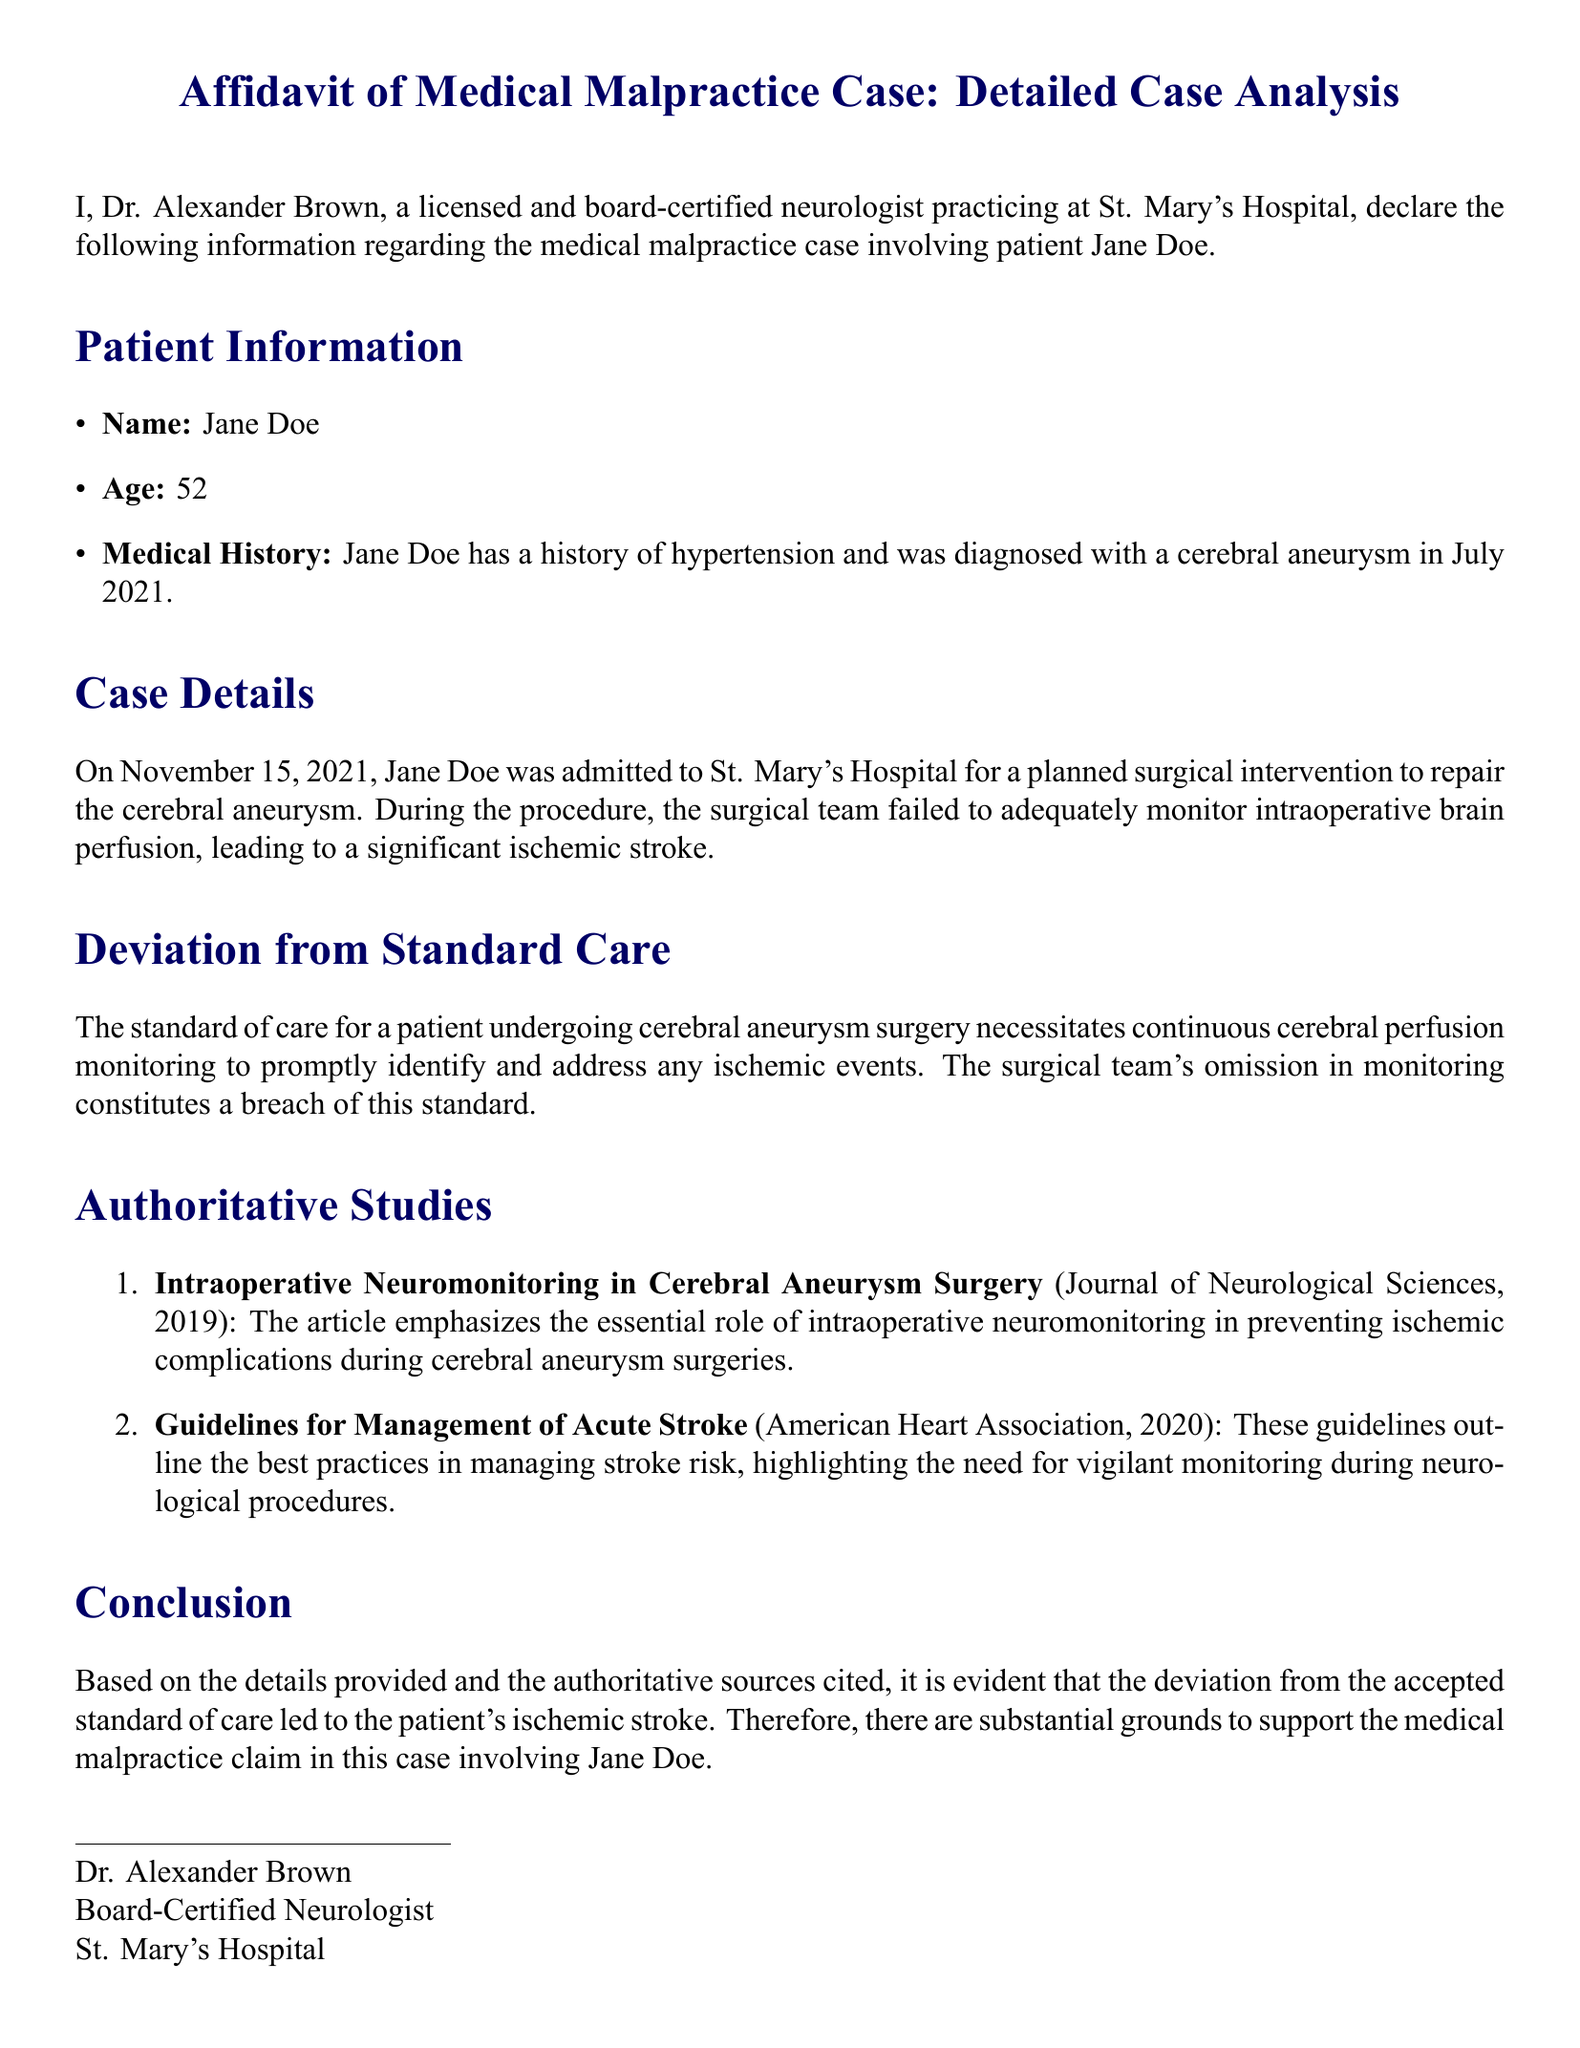What is the name of the patient? The first item in the Patient Information section states that the patient's name is Jane Doe.
Answer: Jane Doe What procedure was Jane Doe admitted for? The Case Details section mentions that Jane Doe was admitted for a surgical intervention to repair her cerebral aneurysm.
Answer: Surgical intervention to repair cerebral aneurysm What was the date of Jane Doe's admission to the hospital? The document specifies that Jane Doe was admitted on November 15, 2021.
Answer: November 15, 2021 What major medical event occurred during the surgical procedure? The Case Details section indicates that a significant ischemic stroke occurred during the procedure.
Answer: Significant ischemic stroke What is the standard of care mentioned in the affidavit? The Deviation from Standard Care section describes that continuous cerebral perfusion monitoring is the standard of care during cerebral aneurysm surgery.
Answer: Continuous cerebral perfusion monitoring Which organization issued guidelines related to stroke management referenced in the document? The Authoritative Studies section lists the American Heart Association as the organization that outlined guidelines for managing acute stroke.
Answer: American Heart Association What year was the study about intraoperative neuromonitoring published? The Authoritative Studies section provides the publication year of the study as 2019.
Answer: 2019 Who authored the affidavit? The Conclusion section provides the author's name as Dr. Alexander Brown.
Answer: Dr. Alexander Brown What is the professional title of Dr. Brown? The end of the document states that Dr. Alexander Brown is identified as a Board-Certified Neurologist.
Answer: Board-Certified Neurologist 